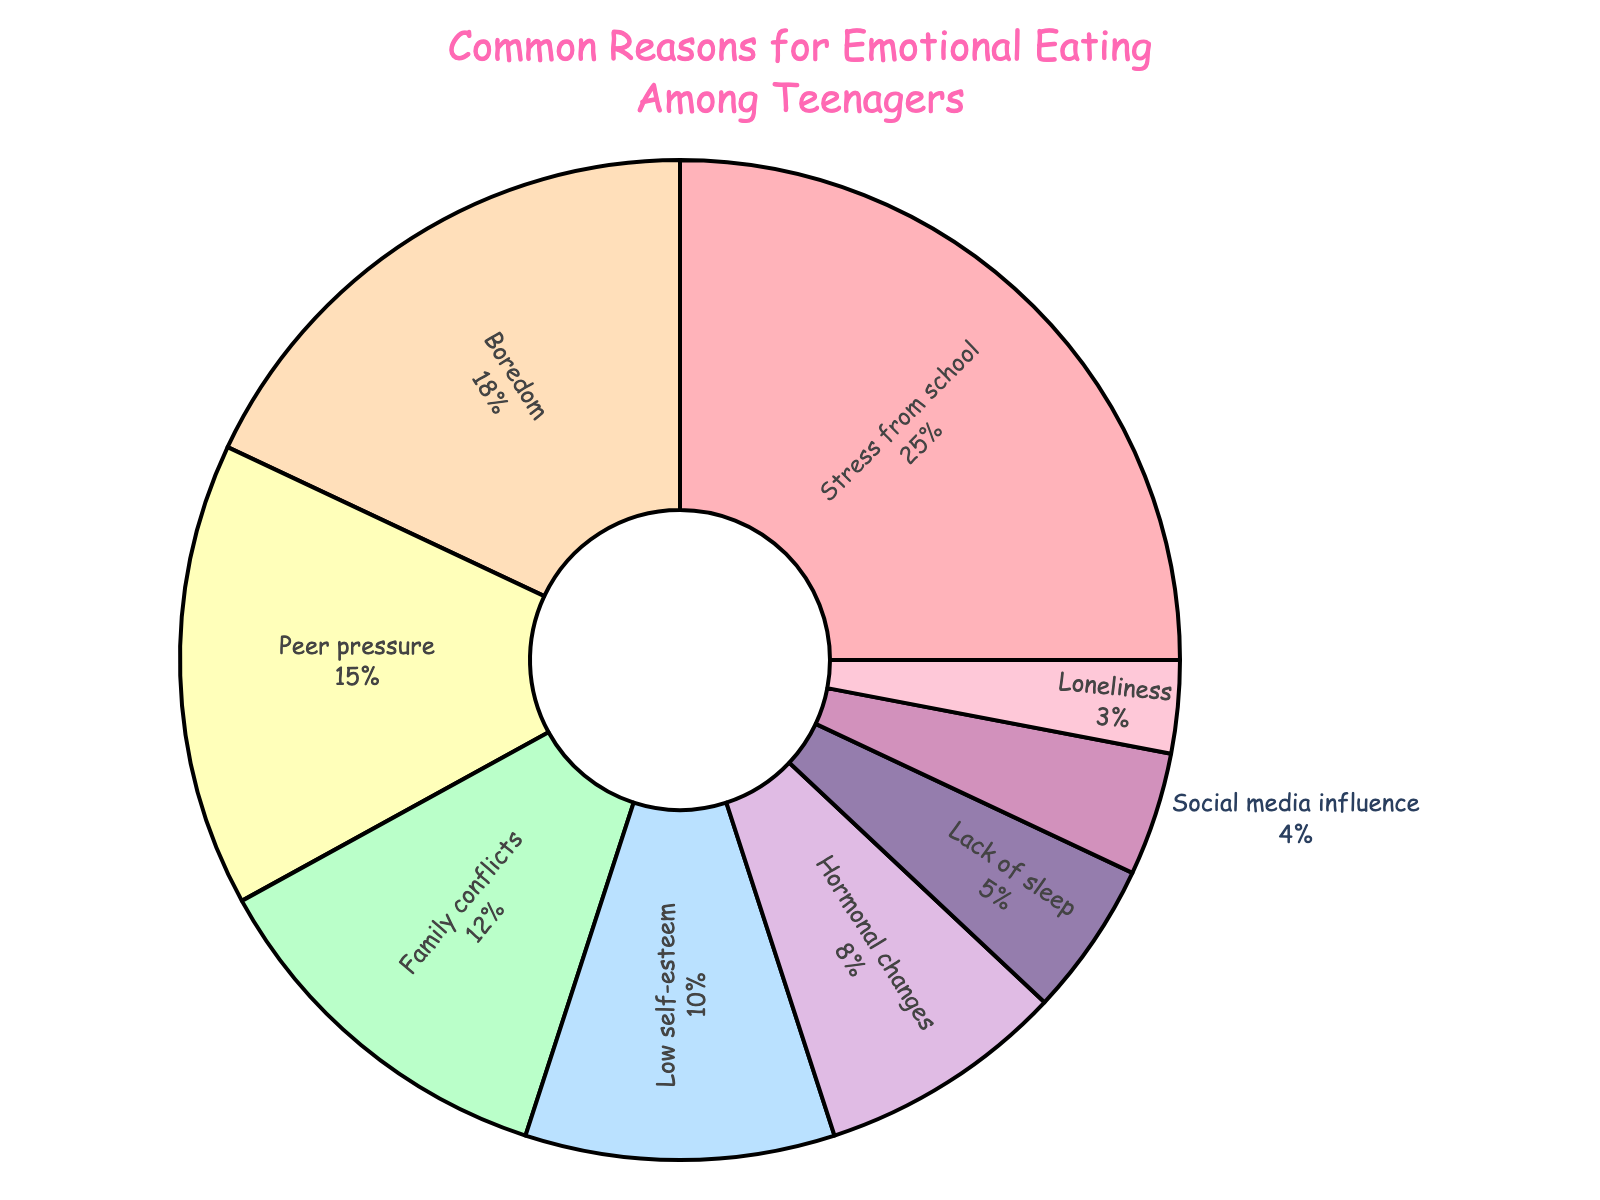What is the most common reason for emotional eating among teenagers? The chart shows a pie where "Stress from school" occupies the largest segment.
Answer: Stress from school What percentage of teenagers emotionally eat due to boredom? The segment labeled "Boredom" represents 18% of the pie.
Answer: 18% Which reason has a higher percentage, peer pressure or hormonal changes? By comparing the sizes of the segments, "Peer pressure" is 15% and "Hormonal changes" is 8%. Peer pressure has a higher percentage.
Answer: Peer pressure How do the percentages of family conflicts and low self-esteem compare? The segment for "Family conflicts" is labeled 12%, and "Low self-esteem" is 10%. Family conflicts have a larger percentage.
Answer: Family conflicts What can you infer from the fact that the social media influence section is very small? The pie section for "Social media influence" is labeled 4%, showing it's one of the less common reasons for emotional eating among teenagers.
Answer: It’s less common Which reason has the smallest percentage for emotional eating, and what is that percentage? The smallest pie segment is labeled "Loneliness" and shows 3%.
Answer: Loneliness, 3% What is the combined percentage of teenagers who emotionally eat due to stress from school, boredom, and family conflicts? Adding the percentages for "Stress from school" (25%), "Boredom" (18%), and "Family conflicts" (12%) gives 25 + 18 + 12 = 55%.
Answer: 55% Compare the combined percentage of hormonal changes and lack of sleep to peer pressure. Adding the percentages for "Hormonal changes" (8%) and "Lack of sleep" (5%) gives 8 + 5 = 13%, which is less than "Peer pressure" (15%).
Answer: Peer pressure is higher Which two reasons combined are just slightly less than the percentage for stress from school? Adding the percentages for "Boredom" (18%) and "Peer pressure" (15%) gives 18 + 15 = 33%, which is 8% higher than "Stress from school" (25%). The closest lower sum would be "Peer pressure" (15%) and "Family conflicts" (12%) which total 27%, slightly higher but closer when compared sequentially.
Answer: Peer pressure and low self-esteem What percentage of teenagers emotionally eat due to factors related to personal feelings (low self-esteem, loneliness, and lack of sleep)? Adding the percentages for "Low self-esteem" (10%), "Loneliness" (3%), and "Lack of sleep" (5%) gives 10 + 3 + 5 = 18%.
Answer: 18% 